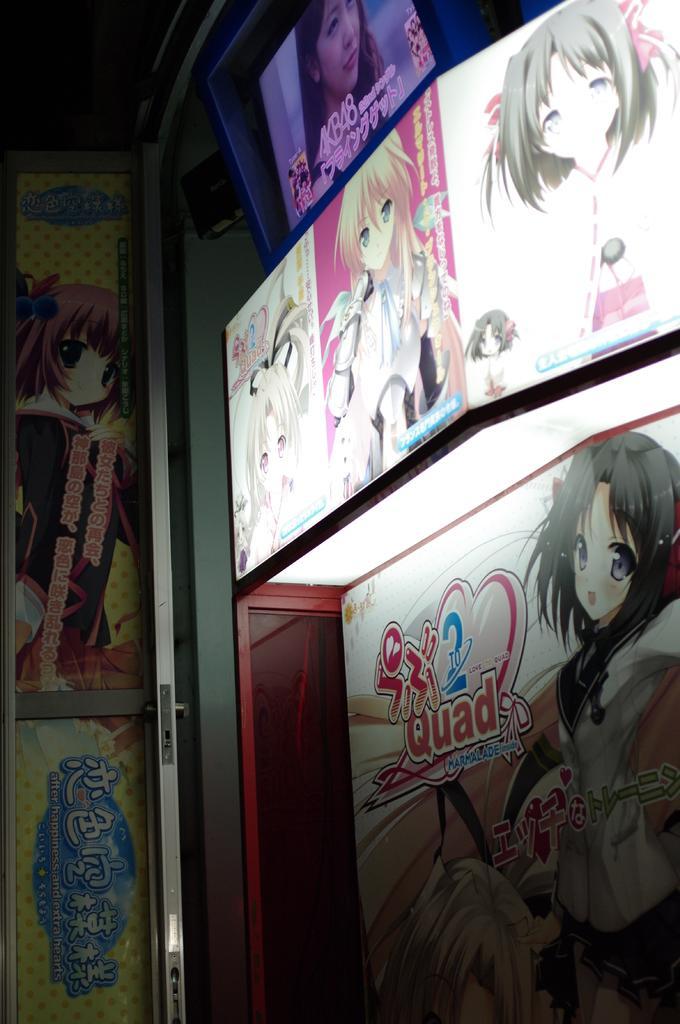Describe this image in one or two sentences. In this image we can see advertising boards. On advertising boards, we can see an animation of persons and some text on it in the image. 